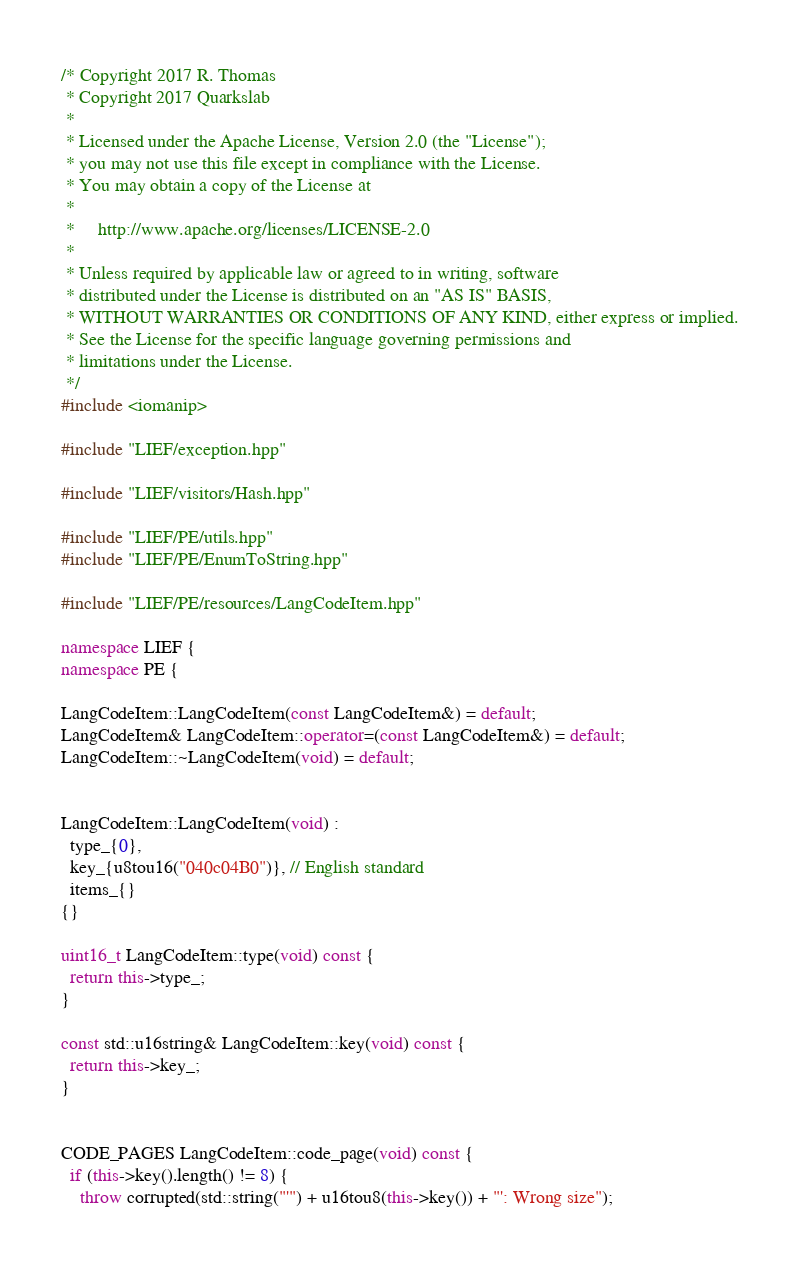<code> <loc_0><loc_0><loc_500><loc_500><_C++_>/* Copyright 2017 R. Thomas
 * Copyright 2017 Quarkslab
 *
 * Licensed under the Apache License, Version 2.0 (the "License");
 * you may not use this file except in compliance with the License.
 * You may obtain a copy of the License at
 *
 *     http://www.apache.org/licenses/LICENSE-2.0
 *
 * Unless required by applicable law or agreed to in writing, software
 * distributed under the License is distributed on an "AS IS" BASIS,
 * WITHOUT WARRANTIES OR CONDITIONS OF ANY KIND, either express or implied.
 * See the License for the specific language governing permissions and
 * limitations under the License.
 */
#include <iomanip>

#include "LIEF/exception.hpp"

#include "LIEF/visitors/Hash.hpp"

#include "LIEF/PE/utils.hpp"
#include "LIEF/PE/EnumToString.hpp"

#include "LIEF/PE/resources/LangCodeItem.hpp"

namespace LIEF {
namespace PE {

LangCodeItem::LangCodeItem(const LangCodeItem&) = default;
LangCodeItem& LangCodeItem::operator=(const LangCodeItem&) = default;
LangCodeItem::~LangCodeItem(void) = default;


LangCodeItem::LangCodeItem(void) :
  type_{0},
  key_{u8tou16("040c04B0")}, // English standard
  items_{}
{}

uint16_t LangCodeItem::type(void) const {
  return this->type_;
}

const std::u16string& LangCodeItem::key(void) const {
  return this->key_;
}


CODE_PAGES LangCodeItem::code_page(void) const {
  if (this->key().length() != 8) {
    throw corrupted(std::string("'") + u16tou8(this->key()) + "': Wrong size");</code> 